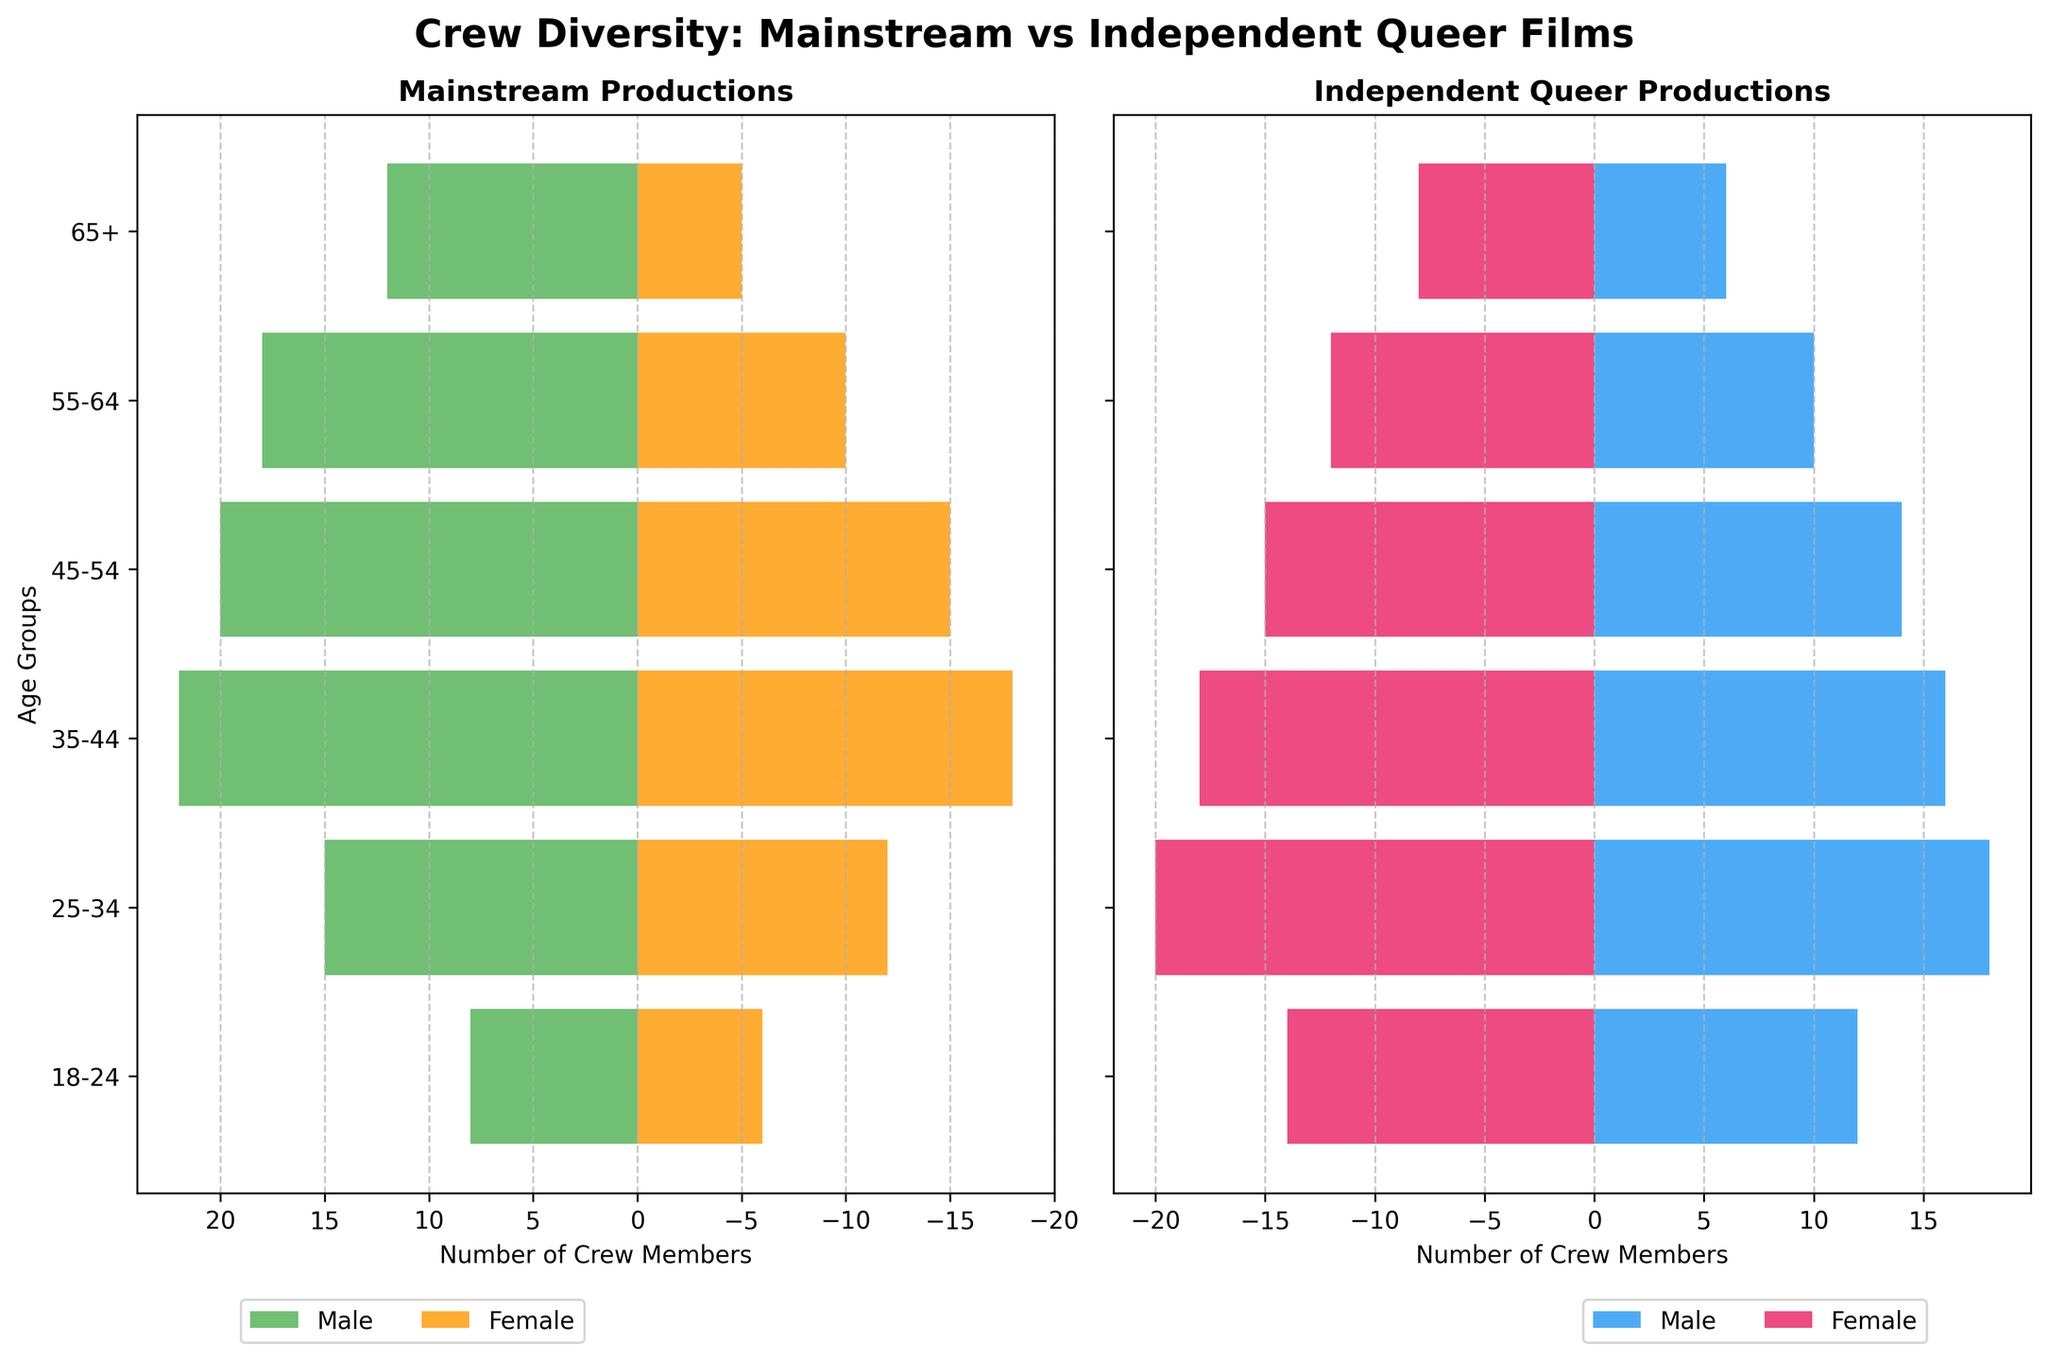How many female crew members are in the 25-34 age group for mainstream productions? Look at the bar for the 25-34 age group in the Mainstream Productions plot. The female bar extends leftward to -12.
Answer: 12 Which crew category (mainstream or independent) has more male crew members in the 35-44 age group? Compare the height of the male bars for the 35-44 age group in both plots. Mainstream has 22 while Independent has 16.
Answer: Mainstream What is the total number of crew members in the 65+ age group for independent queer films? Sum the absolute value of the male and female bars for the 65+ age group in the Independent Queer Productions plot. Male is 6 and Female is 8, so 6 + 8 = 14.
Answer: 14 How do the numbers of male and female crew members compare in the 55-64 age group for mainstream productions? Compare the lengths of the male and female bars for the 55-64 age group in the Mainstream Productions plot. Male extends to 18 and Female extends to -10.
Answer: More males In which age group does independent queer productions have the highest number of female crew members? Look for the age group where the female bar extends the farthest leftwards in the Independent Queer Productions plot. The 25-34 age group has the longest bar to -20.
Answer: 25-34 Are there more female crew members in the 18-24 age group for independent or mainstream productions? Compare the lengths of the female bars for the 18-24 age group in both plots. Independent extends to -14 while Mainstream extends to -6.
Answer: Independent What is the combined total of male crew members across all age groups for mainstream productions? Add the values of the male bars across all age groups in the Mainstream Productions plot: 8 + 15 + 22 + 20 + 18 + 12 = 95.
Answer: 95 In which age group is the difference between male and female crew members the largest for independent productions? For each age group in the Independent Queer Productions plot, calculate the absolute difference between the male and female bars:
Answer: 25-34 Which age group has the least number of crew members in mainstream productions? Sum the absolute values of the male and female bars for each age group in the Mainstream Productions plot and find the minimum: 18-24 has 8+6=14, 25-34 has 15+12=27, etc. The last age group 65+ has the minimum total: 12+5=17.
Answer: 18-24 How does the diversity within the 35-44 age group compare between mainstream and independent productions? Compare both the male and female bars for the 35-44 age group in both plots. Mainstream has 22 males and 18 females; Independent has 16 males and 18 females. There is a greater male presence in mainstream, but both have equal women presence.
Answer: Mainstream more males, both equal females 